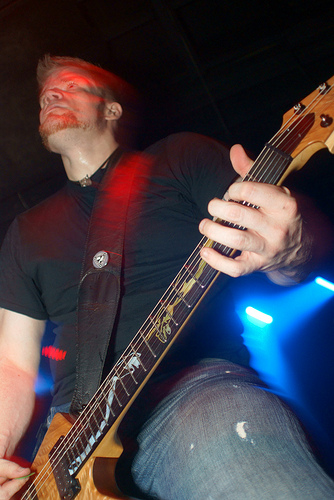<image>
Is the man behind the guitar? Yes. From this viewpoint, the man is positioned behind the guitar, with the guitar partially or fully occluding the man. 